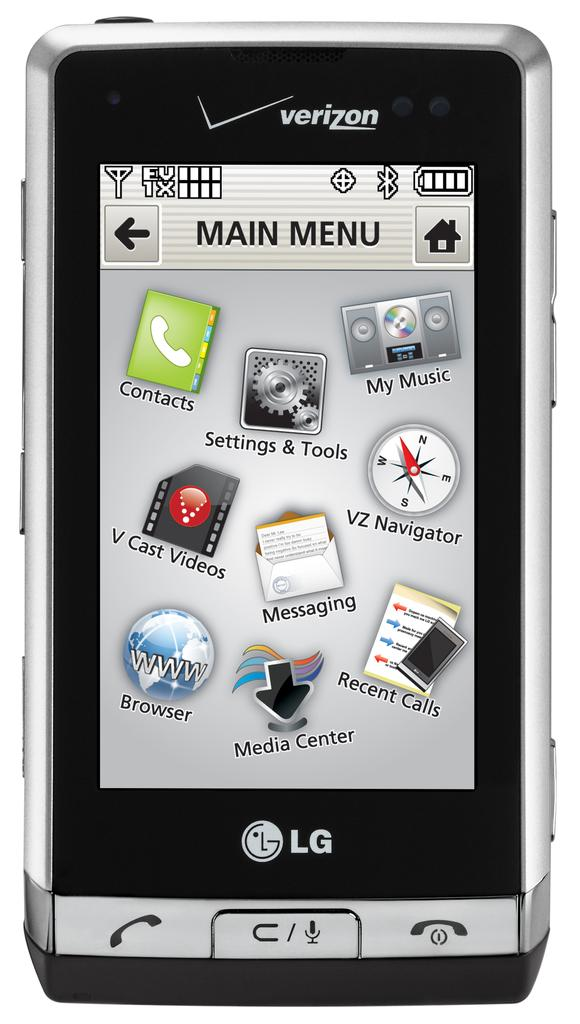Provide a one-sentence caption for the provided image. A verizon supported LG phone with the main menu on the screen. 